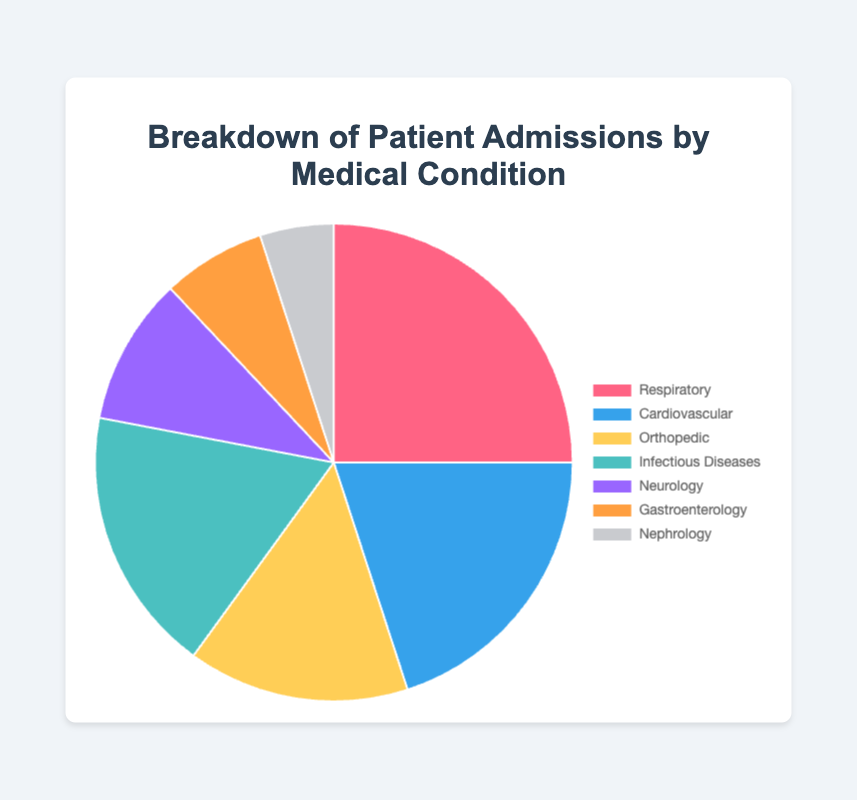what is the percentage of patients admitted for Respiratory conditions? From the pie chart, the segment labeled "Respiratory" represents the proportion of patients admitted for this condition. The corresponding data percentage for Respiratory conditions is 25%.
Answer: 25% Which condition has the lowest percentage of patient admissions? By examining the pie chart's segments, "Nephrology" stands with the smallest slice, indicating it has the lowest percentage. The data confirms Nephrology has 5%.
Answer: Nephrology How much higher in percentage is the Respiratory condition compared to Gastroenterology? The Respiratory condition is 25%, and Gastroenterology is 7%. Subtract the two to see how much higher Respiratory is compared to Gastroenterology: 25% - 7% = 18%.
Answer: 18% What is the combined percentage of patients admitted for Cardiovascular and Orthopedic conditions? According to the data, Cardiovascular is 20% and Orthopedic is 15%. Adding these gives the combined percentage: 20% + 15% = 35%.
Answer: 35% Which condition has more admissions, Infectious Diseases or Neurology? Referencing the pie chart, the segment for Infectious Diseases appears larger than that for Neurology. Confirming this, the data shows Infectious Diseases at 18% and Neurology at 10%. Therefore, Infectious Diseases has more admissions.
Answer: Infectious Diseases What is the total percentage of admissions for Respiratory, Cardiovascular, and Neurology conditions combined? Referencing the data, Respiratory is 25%, Cardiovascular is 20%, and Neurology is 10%. Summing these values gives: 25% + 20% + 10% = 55%.
Answer: 55% Is the percentage of Orthopedic admissions greater than that of Gastroenterology and Nephrology combined? Orthopedic admissions are 15%. Gastroenterology is 7% and Nephrology is 5%. Adding the latter two gives: 7% + 5% = 12%. Comparing 15% (Orthopedic) to 12% shows Orthopedic is indeed greater.
Answer: Yes How much more do the Respiratory admissions contribute compared to Nephrology in percentage terms? Respiratory admissions are at 25% and Nephrology at 5%. The difference between the two is 25% - 5% = 20%.
Answer: 20% If the hospital has 1000 total admissions, how many were admitted for Cardiovascular conditions? Cardiovascular conditions represent 20% of total admissions. For 1000 admissions, the number for Cardiovascular is calculated as: 1000 * 0.20 = 200.
Answer: 200 Which conditions have a percentage difference of less than 5% between them? Examining the data, we find that Orthopedic (15%) and Infectious Diseases (18%) differ by 3%, Gastroenterology (7%) and Nephrology (5%) differ by 2%. Both pairs meet the criteria.
Answer: Orthopedic and Infectious Diseases, Gastroenterology and Nephrology 